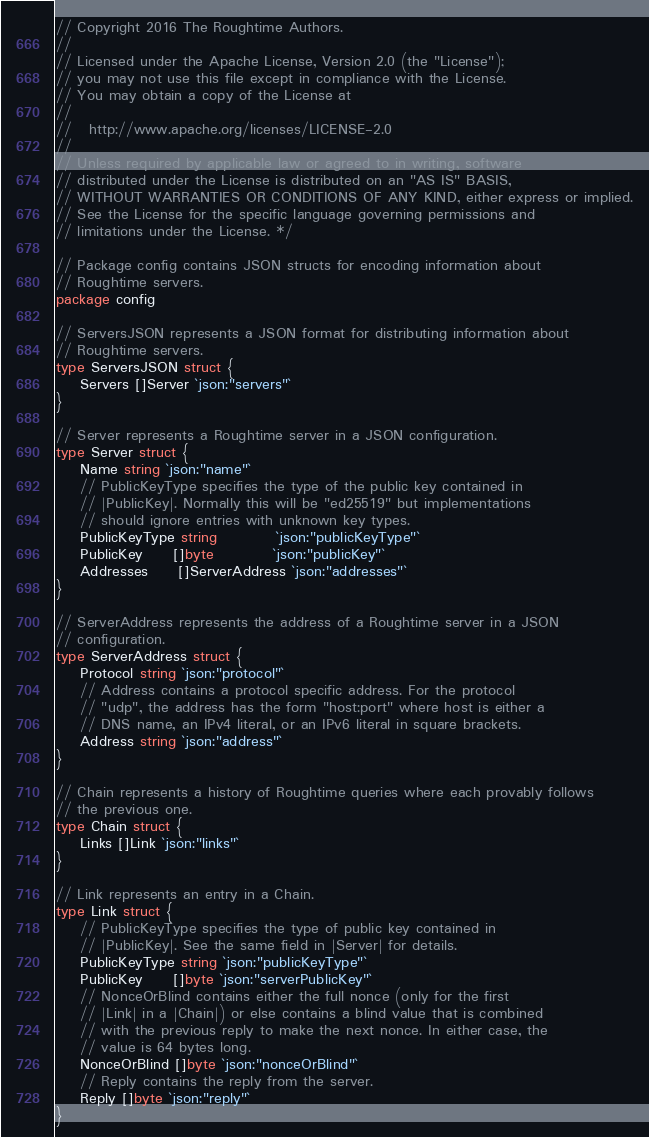Convert code to text. <code><loc_0><loc_0><loc_500><loc_500><_Go_>// Copyright 2016 The Roughtime Authors.
//
// Licensed under the Apache License, Version 2.0 (the "License");
// you may not use this file except in compliance with the License.
// You may obtain a copy of the License at
//
//   http://www.apache.org/licenses/LICENSE-2.0
//
// Unless required by applicable law or agreed to in writing, software
// distributed under the License is distributed on an "AS IS" BASIS,
// WITHOUT WARRANTIES OR CONDITIONS OF ANY KIND, either express or implied.
// See the License for the specific language governing permissions and
// limitations under the License. */

// Package config contains JSON structs for encoding information about
// Roughtime servers.
package config

// ServersJSON represents a JSON format for distributing information about
// Roughtime servers.
type ServersJSON struct {
	Servers []Server `json:"servers"`
}

// Server represents a Roughtime server in a JSON configuration.
type Server struct {
	Name string `json:"name"`
	// PublicKeyType specifies the type of the public key contained in
	// |PublicKey|. Normally this will be "ed25519" but implementations
	// should ignore entries with unknown key types.
	PublicKeyType string          `json:"publicKeyType"`
	PublicKey     []byte          `json:"publicKey"`
	Addresses     []ServerAddress `json:"addresses"`
}

// ServerAddress represents the address of a Roughtime server in a JSON
// configuration.
type ServerAddress struct {
	Protocol string `json:"protocol"`
	// Address contains a protocol specific address. For the protocol
	// "udp", the address has the form "host:port" where host is either a
	// DNS name, an IPv4 literal, or an IPv6 literal in square brackets.
	Address string `json:"address"`
}

// Chain represents a history of Roughtime queries where each provably follows
// the previous one.
type Chain struct {
	Links []Link `json:"links"`
}

// Link represents an entry in a Chain.
type Link struct {
	// PublicKeyType specifies the type of public key contained in
	// |PublicKey|. See the same field in |Server| for details.
	PublicKeyType string `json:"publicKeyType"`
	PublicKey     []byte `json:"serverPublicKey"`
	// NonceOrBlind contains either the full nonce (only for the first
	// |Link| in a |Chain|) or else contains a blind value that is combined
	// with the previous reply to make the next nonce. In either case, the
	// value is 64 bytes long.
	NonceOrBlind []byte `json:"nonceOrBlind"`
	// Reply contains the reply from the server.
	Reply []byte `json:"reply"`
}
</code> 